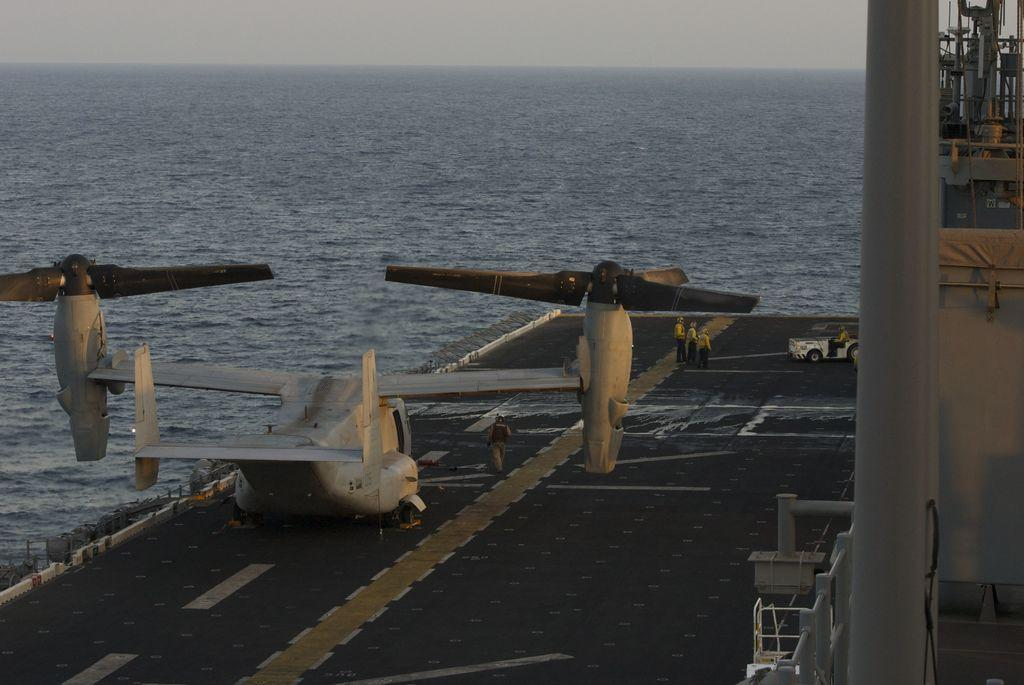What type of aircraft is in the image? There is a tiltrotor in the image. What can be seen in the background of the image? There is water visible in the background of the image. What type of building does the sister own in the image? There is no building or sister present in the image; it features a tiltrotor and water in the background. 